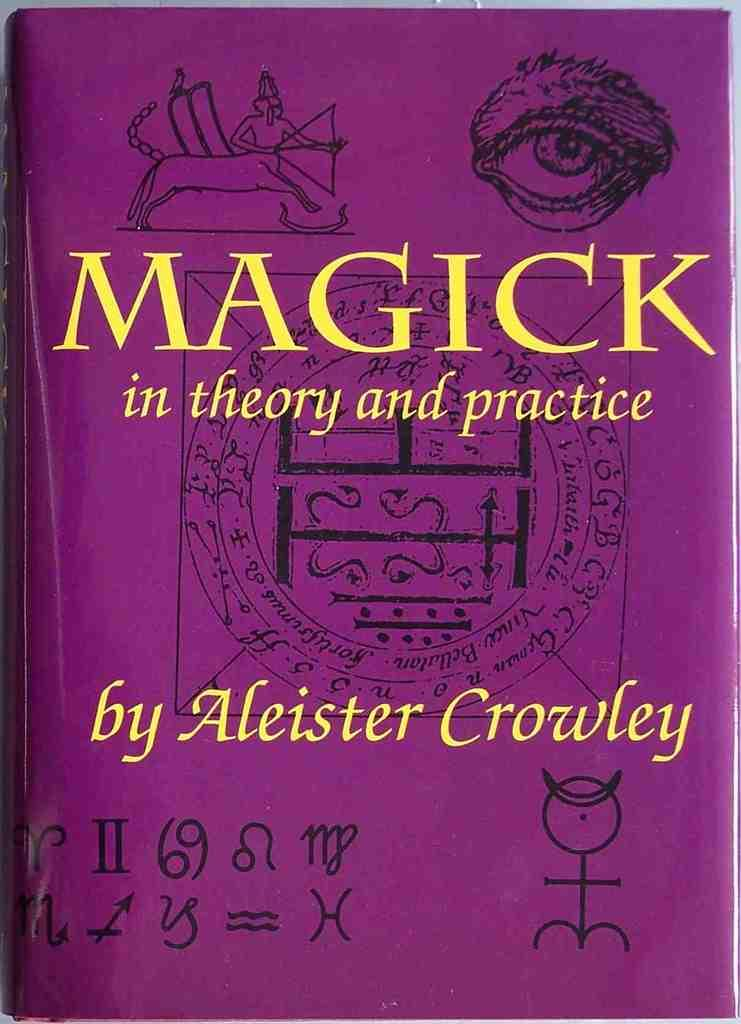<image>
Present a compact description of the photo's key features. The book Magick: in theory and practice written by Aleister Crowley. 